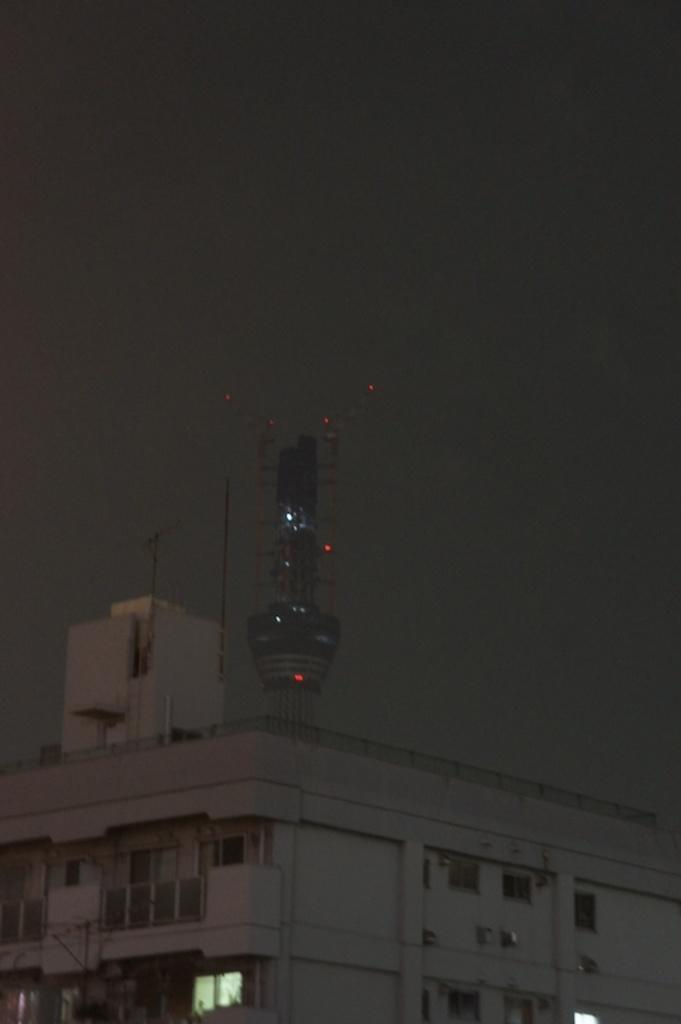What type of structure is in the picture? There is a building in the picture. What feature can be seen on the building? There is a tower on the building. What is visible at the top of the picture? The sky is visible at the top of the picture. What might be used for letting light into the building? There are windows on the building. How many feet are visible on the building in the image? There are no feet visible on the building in the image. What type of impulse can be seen affecting the development of the building in the image? There is no impulse or development process visible in the image; it is a static representation of the building. 